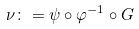<formula> <loc_0><loc_0><loc_500><loc_500>\nu \colon = \psi \circ \varphi ^ { - 1 } \circ G</formula> 